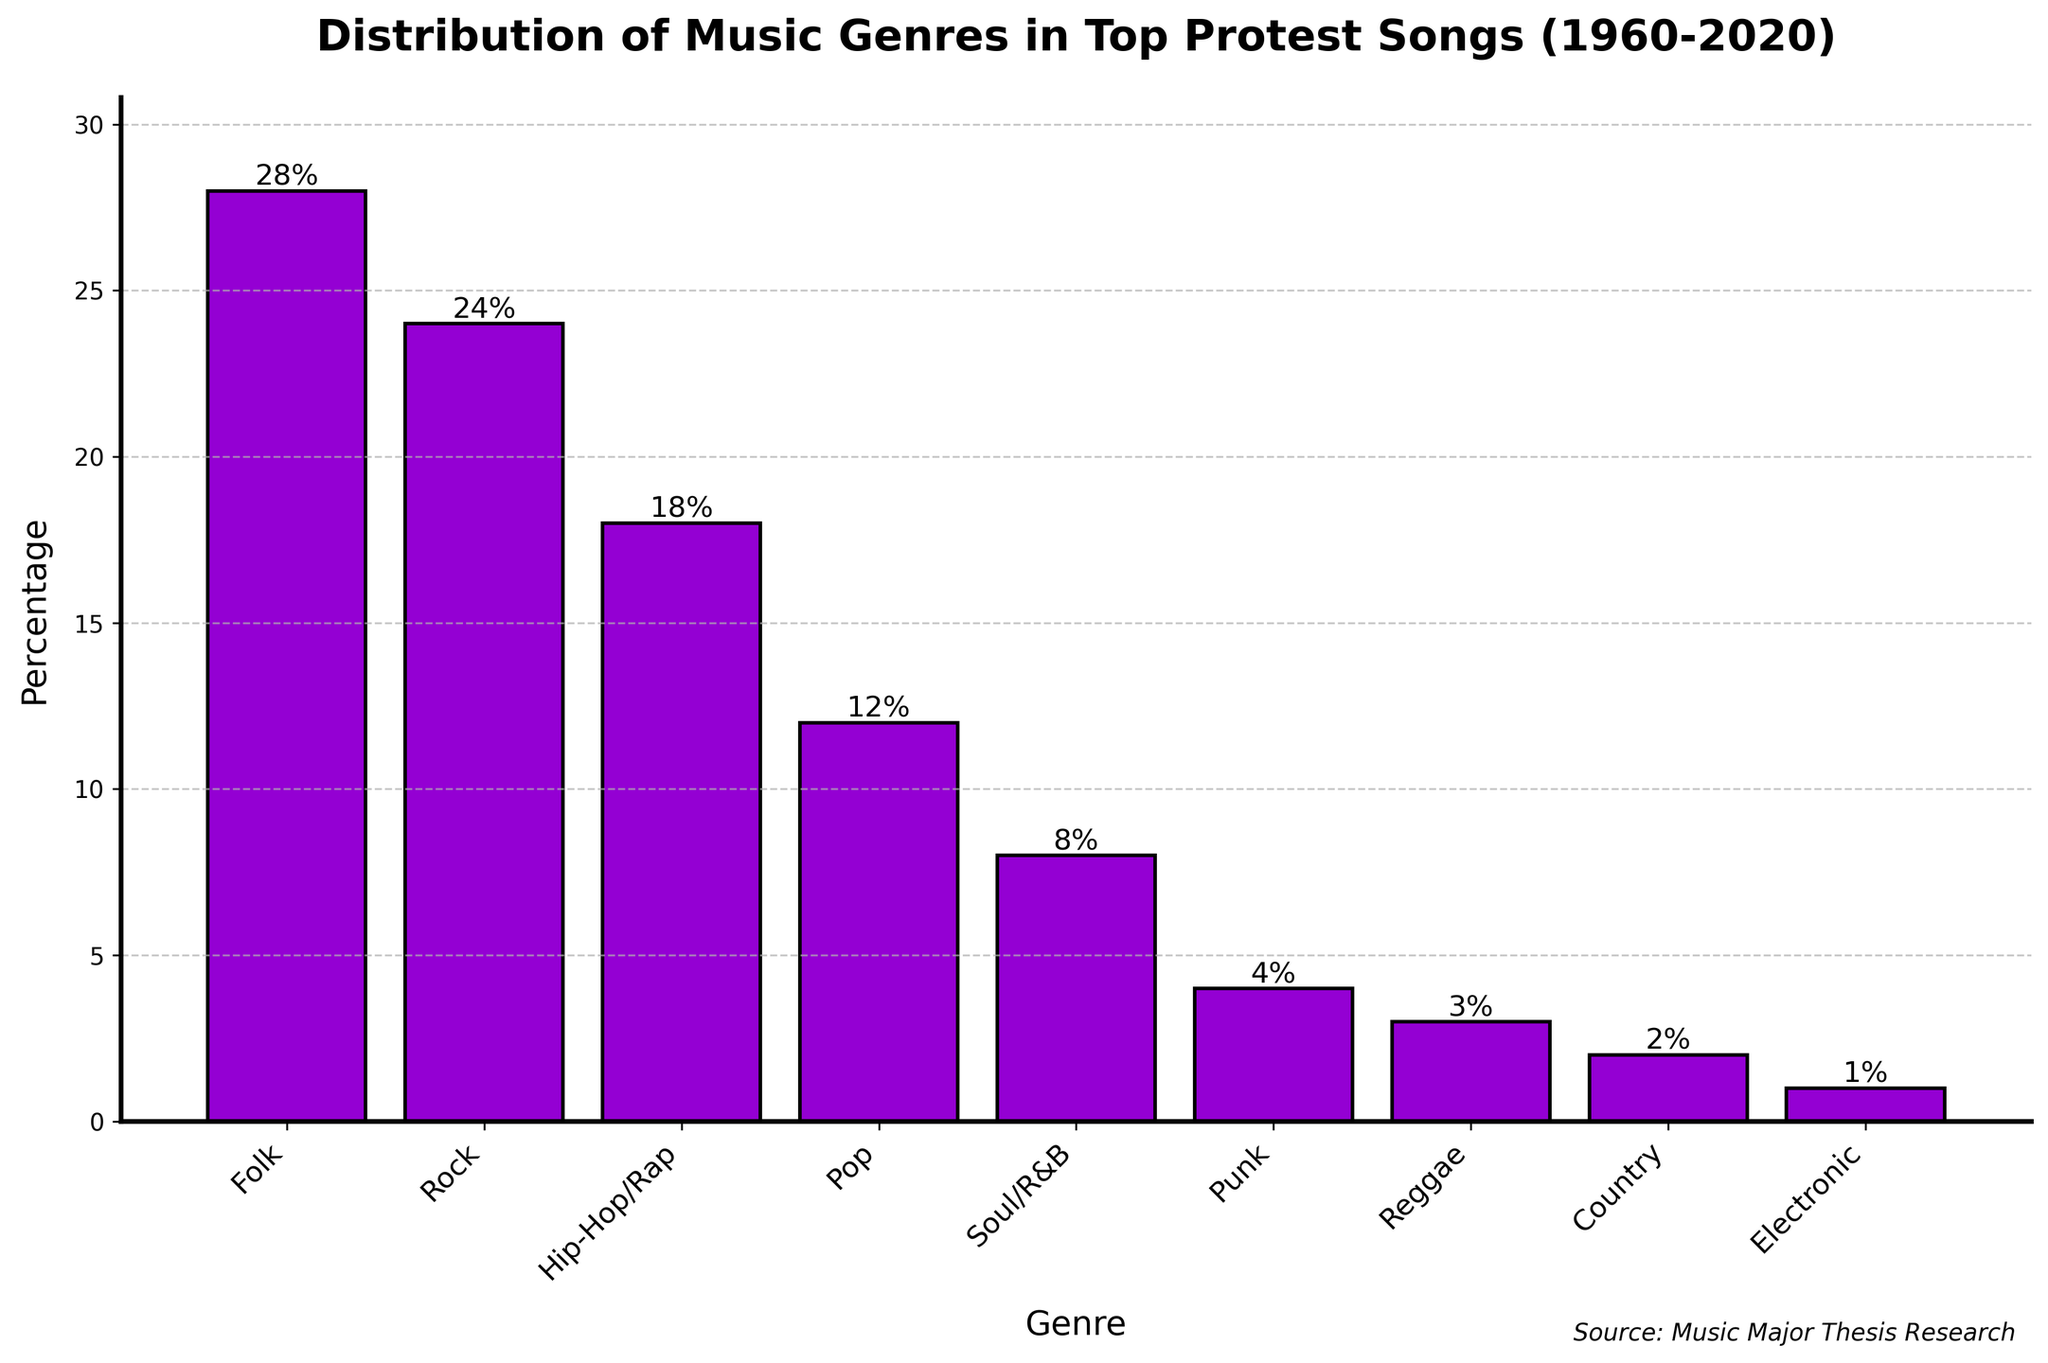What genre has the highest percentage of top protest songs according to the chart? The chart shows various music genres and their percentages. By looking at the height of the bars, the tallest bar represents Folk with a percentage of 28%.
Answer: Folk Which genre has a higher percentage: Pop or Soul/R&B? The heights of the bars indicate the percentage for each genre. Pop has a percentage of 12%, while Soul/R&B has a percentage of 8%. Since 12% is greater than 8%, Pop has a higher percentage.
Answer: Pop What is the combined percentage of Hip-Hop/Rap and Punk genres? Add the percentages of Hip-Hop/Rap and Punk. Hip-Hop/Rap has 18% and Punk has 4%, so their combined percentage is 18% + 4% = 22%.
Answer: 22% By how much does the percentage of Rock exceed that of Reggae? Subtract the percentage of Reggae from the percentage of Rock. Rock has 24% and Reggae has 3%, so the difference is 24% - 3% = 21%.
Answer: 21% How much less is the percentage of Country compared to Soul/R&B? Subtract the percentage of Country from the percentage of Soul/R&B. Soul/R&B has 8% and Country has 2%, so the difference is 8% - 2% = 6%.
Answer: 6% Which genre has the lowest percentage of top protest songs? Observe the height of the bars. The shortest bar represents Electronic with a percentage of 1%.
Answer: Electronic What are the top three genres with the highest percentages? Sort the percentages in descending order. The top three percentages are 28% (Folk), 24% (Rock), and 18% (Hip-Hop/Rap). Therefore, the top three genres are Folk, Rock, and Hip-Hop/Rap.
Answer: Folk, Rock, Hip-Hop/Rap Calculate the average percentage of the genres listed in the chart. Sum the percentages and divide by the number of genres: (28% + 24% + 18% + 12% + 8% + 4% + 3% + 2% + 1%) / 9 = 100% / 9 ≈ 11.1%.
Answer: 11.1% What percentage of the top protest songs are from genres other than Folk, Rock, and Hip-Hop/Rap? Calculate the total percentage of Folk, Rock, and Hip-Hop/Rap and subtract from 100%. Folk is 28%, Rock is 24%, and Hip-Hop/Rap is 18%, so the total is 28% + 24% + 18% = 70%. 100% - 70% = 30%.
Answer: 30% 